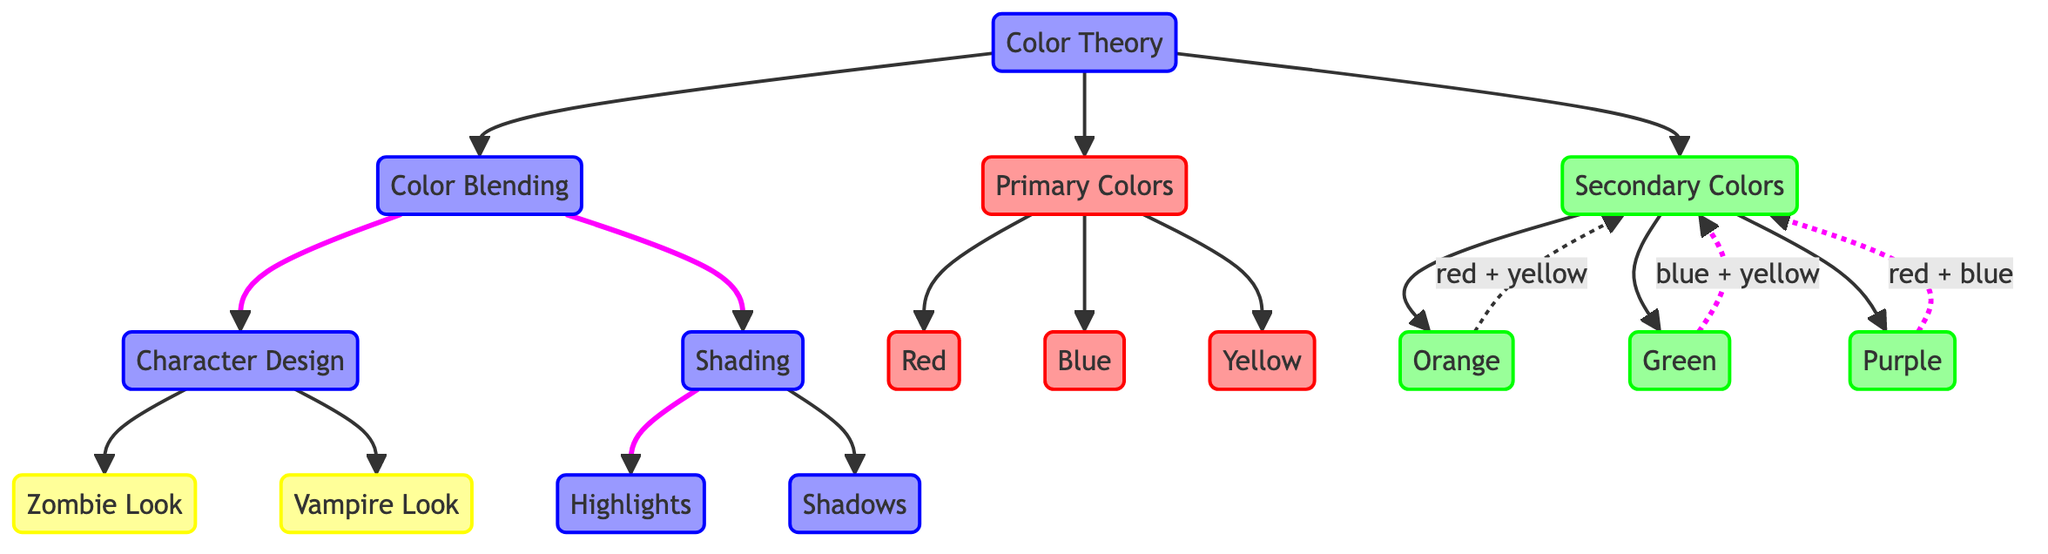What are the primary colors listed in the diagram? The diagram directly lists three primary colors: Red, Blue, and Yellow, identified under the "Primary Colors" node connected to "Color Theory."
Answer: Red, Blue, Yellow How many secondary colors can be identified from the diagram? The secondary colors are Orange, Green, and Purple, totaling three colors as indicated under the "Secondary Colors" node.
Answer: Three Which two primary colors combine to form green? The diagram specifies that Blue and Yellow combine to create Green, indicated by the line leading from those colors to the Green node under "Secondary Colors."
Answer: Blue and Yellow What concepts are directly connected to color blending? "Character Design" and "Shading" are the two concepts that are directly connected to the "Color Blending" node, as shown in the diagram's layout.
Answer: Character Design, Shading Which character looks are associated with color theory in the diagram? The diagram shows two character looks: Zombie and Vampire, both linked from the "Character Design" node.
Answer: Zombie, Vampire How do highlights and shadows relate to shading in this diagram? Highlights and Shadows are both branched out from the "Shading" node in the diagram, indicating that they are integral components of shading techniques in color theory.
Answer: Highlights, Shadows What happens to the colors red and yellow in the diagram? The diagram illustrates that combining Red and Yellow results in Orange, shown by the dashed line connecting these colors to the Orange node under "Secondary Colors."
Answer: Orange Which primary colors are needed to create the color purple? The diagram indicates that Purple is formed by blending Red and Blue, which are displayed as contributing colors in the secondary colors section.
Answer: Red and Blue How many edges connect to the "Color Theory" node? The node for "Color Theory" has three outgoing edges connecting to "Primary Colors," "Secondary Colors," and "Color Blending," totaling three edges.
Answer: Three 